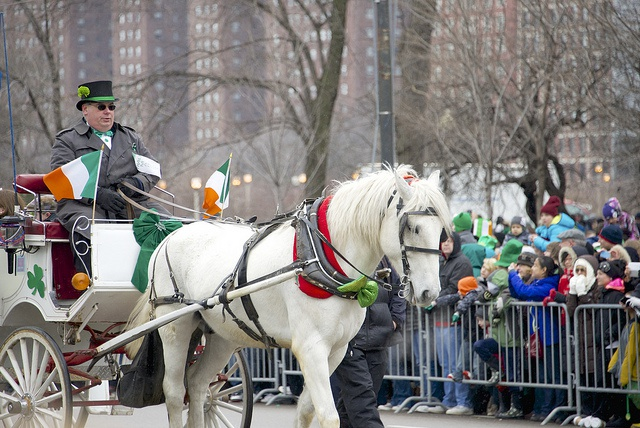Describe the objects in this image and their specific colors. I can see horse in gray, lightgray, and darkgray tones, people in gray, black, and darkgray tones, people in gray, black, darkgray, and white tones, people in gray, black, navy, and darkblue tones, and people in gray, black, and darkgray tones in this image. 